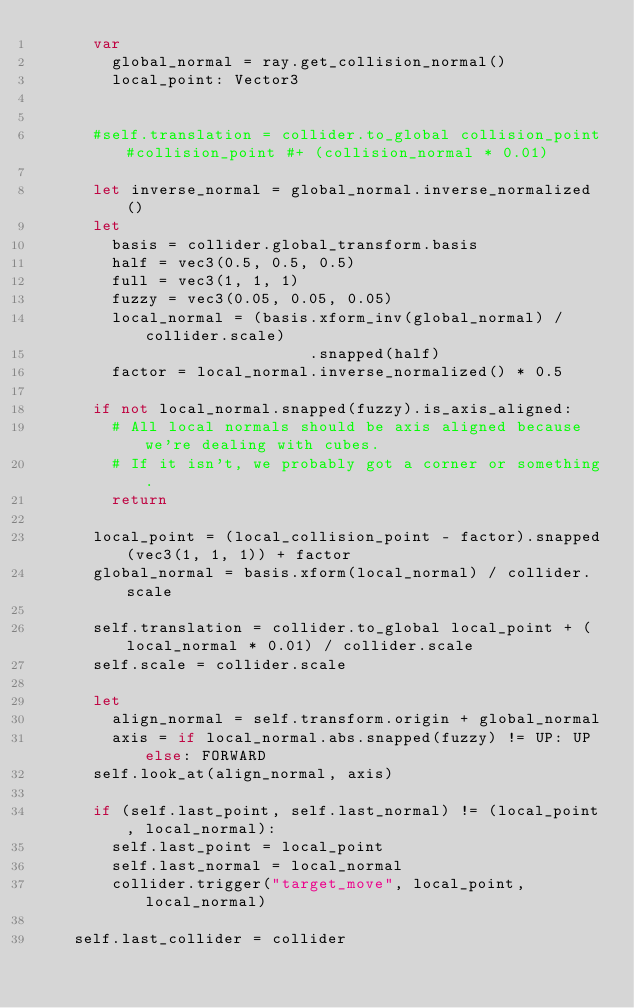<code> <loc_0><loc_0><loc_500><loc_500><_Nim_>      var
        global_normal = ray.get_collision_normal()
        local_point: Vector3


      #self.translation = collider.to_global collision_point#collision_point #+ (collision_normal * 0.01)

      let inverse_normal = global_normal.inverse_normalized()
      let
        basis = collider.global_transform.basis
        half = vec3(0.5, 0.5, 0.5)
        full = vec3(1, 1, 1)
        fuzzy = vec3(0.05, 0.05, 0.05)
        local_normal = (basis.xform_inv(global_normal) / collider.scale)
                             .snapped(half)
        factor = local_normal.inverse_normalized() * 0.5

      if not local_normal.snapped(fuzzy).is_axis_aligned:
        # All local normals should be axis aligned because we're dealing with cubes.
        # If it isn't, we probably got a corner or something.
        return

      local_point = (local_collision_point - factor).snapped(vec3(1, 1, 1)) + factor
      global_normal = basis.xform(local_normal) / collider.scale

      self.translation = collider.to_global local_point + (local_normal * 0.01) / collider.scale
      self.scale = collider.scale

      let
        align_normal = self.transform.origin + global_normal
        axis = if local_normal.abs.snapped(fuzzy) != UP: UP else: FORWARD
      self.look_at(align_normal, axis)

      if (self.last_point, self.last_normal) != (local_point, local_normal):
        self.last_point = local_point
        self.last_normal = local_normal
        collider.trigger("target_move", local_point, local_normal)

    self.last_collider = collider
</code> 